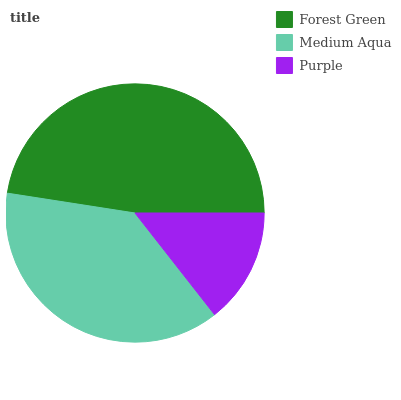Is Purple the minimum?
Answer yes or no. Yes. Is Forest Green the maximum?
Answer yes or no. Yes. Is Medium Aqua the minimum?
Answer yes or no. No. Is Medium Aqua the maximum?
Answer yes or no. No. Is Forest Green greater than Medium Aqua?
Answer yes or no. Yes. Is Medium Aqua less than Forest Green?
Answer yes or no. Yes. Is Medium Aqua greater than Forest Green?
Answer yes or no. No. Is Forest Green less than Medium Aqua?
Answer yes or no. No. Is Medium Aqua the high median?
Answer yes or no. Yes. Is Medium Aqua the low median?
Answer yes or no. Yes. Is Purple the high median?
Answer yes or no. No. Is Purple the low median?
Answer yes or no. No. 